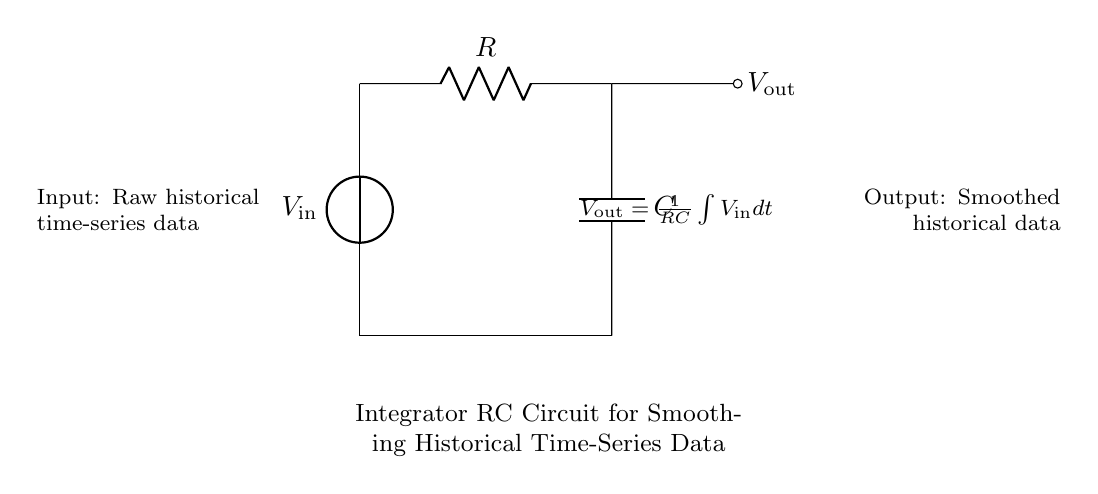What is the type of circuit shown? The circuit is an integrator RC circuit, which is designed to integrate the input voltage over time to produce a smoothed output.
Answer: Integrator RC circuit What components are present in the circuit? The circuit contains a voltage source, a resistor, and a capacitor. These are essential components for the function of an integrator.
Answer: Voltage source, resistor, capacitor What is the relationship expressed in the circuit for the output voltage? The relationship described indicates that the output voltage is proportional to the integral of the input voltage, scaled by the factor \( \frac{1}{RC} \). This shows how the input data contributes to the smoothed output.
Answer: V out = (1/RC) ∫ V in dt What is the purpose of this RC circuit? The main purpose of this integrator RC circuit is to smooth out irregularities in time-series historical data, transforming raw input into a cherished output.
Answer: Smoothing historical data How do the resistor and capacitor interact? In this circuit, the resistor limits the rate of charge (or discharge) of the capacitor, affecting how quickly the output can respond to changes in the input voltage. This interaction determines the time constant \( \tau = RC \) of the circuit.
Answer: Limits charge rate What happens to the output if the input voltage increases steadily? If the input voltage consistently increases, the output voltage will also rise, effectively representing the cumulative integral of that input, thus smoothing the variation over time.
Answer: Output rises How does the capacitor affect the circuit's response to rapid changes in input? The capacitor introduces a lag in the output response to rapid changes in input. Since capacitors resist sudden changes in voltage, they delay the output, leading to a smoothing effect.
Answer: Introduces lag 